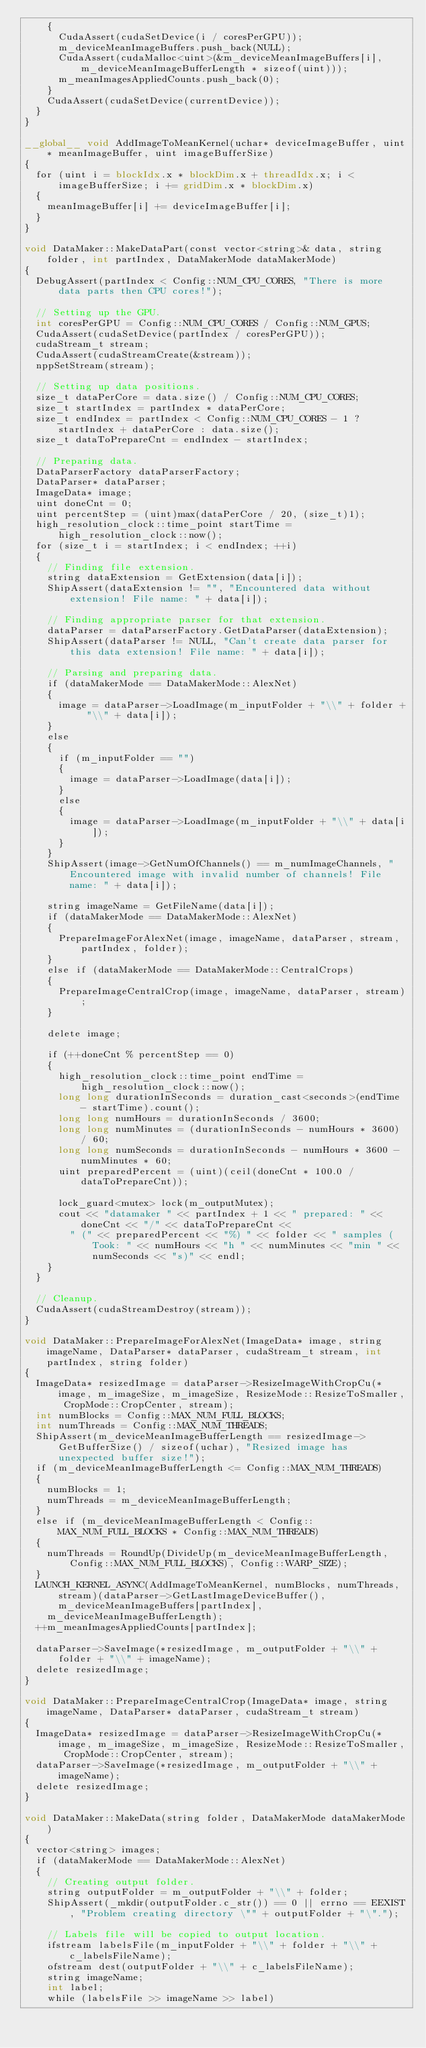<code> <loc_0><loc_0><loc_500><loc_500><_Cuda_>		{
			CudaAssert(cudaSetDevice(i / coresPerGPU));
			m_deviceMeanImageBuffers.push_back(NULL);
			CudaAssert(cudaMalloc<uint>(&m_deviceMeanImageBuffers[i], m_deviceMeanImageBufferLength * sizeof(uint)));
			m_meanImagesAppliedCounts.push_back(0);
		}
		CudaAssert(cudaSetDevice(currentDevice));
	}
}

__global__ void AddImageToMeanKernel(uchar* deviceImageBuffer, uint* meanImageBuffer, uint imageBufferSize)
{
	for (uint i = blockIdx.x * blockDim.x + threadIdx.x; i < imageBufferSize; i += gridDim.x * blockDim.x)
	{
		meanImageBuffer[i] += deviceImageBuffer[i];
	}
}

void DataMaker::MakeDataPart(const vector<string>& data, string folder, int partIndex, DataMakerMode dataMakerMode)
{
	DebugAssert(partIndex < Config::NUM_CPU_CORES, "There is more data parts then CPU cores!");

	// Setting up the GPU.
	int coresPerGPU = Config::NUM_CPU_CORES / Config::NUM_GPUS;
	CudaAssert(cudaSetDevice(partIndex / coresPerGPU));
	cudaStream_t stream;
	CudaAssert(cudaStreamCreate(&stream));
	nppSetStream(stream);

	// Setting up data positions.
	size_t dataPerCore = data.size() / Config::NUM_CPU_CORES;
	size_t startIndex = partIndex * dataPerCore;
	size_t endIndex = partIndex < Config::NUM_CPU_CORES - 1 ? startIndex + dataPerCore : data.size();
	size_t dataToPrepareCnt = endIndex - startIndex;
	
	// Preparing data.
	DataParserFactory dataParserFactory;
	DataParser* dataParser;
	ImageData* image;
	uint doneCnt = 0;
	uint percentStep = (uint)max(dataPerCore / 20, (size_t)1);
	high_resolution_clock::time_point startTime = high_resolution_clock::now();
	for (size_t i = startIndex; i < endIndex; ++i)
	{
		// Finding file extension.
		string dataExtension = GetExtension(data[i]);
		ShipAssert(dataExtension != "", "Encountered data without extension! File name: " + data[i]);

		// Finding appropriate parser for that extension.
		dataParser = dataParserFactory.GetDataParser(dataExtension);
		ShipAssert(dataParser != NULL, "Can't create data parser for this data extension! File name: " + data[i]);

		// Parsing and preparing data.
		if (dataMakerMode == DataMakerMode::AlexNet)
		{
			image = dataParser->LoadImage(m_inputFolder + "\\" + folder + "\\" + data[i]);
		}
		else
		{
			if (m_inputFolder == "")
			{
				image = dataParser->LoadImage(data[i]);
			}
			else
			{
				image = dataParser->LoadImage(m_inputFolder + "\\" + data[i]);
			}
		}
		ShipAssert(image->GetNumOfChannels() == m_numImageChannels, "Encountered image with invalid number of channels! File name: " + data[i]);

		string imageName = GetFileName(data[i]);
		if (dataMakerMode == DataMakerMode::AlexNet)
		{
			PrepareImageForAlexNet(image, imageName, dataParser, stream, partIndex, folder);
		}
		else if (dataMakerMode == DataMakerMode::CentralCrops)
		{
			PrepareImageCentralCrop(image, imageName, dataParser, stream);
		}

		delete image;

		if (++doneCnt % percentStep == 0)
		{
			high_resolution_clock::time_point endTime = high_resolution_clock::now();
			long long durationInSeconds = duration_cast<seconds>(endTime - startTime).count();
			long long numHours = durationInSeconds / 3600;
			long long numMinutes = (durationInSeconds - numHours * 3600) / 60;
			long long numSeconds = durationInSeconds - numHours * 3600 - numMinutes * 60;
			uint preparedPercent = (uint)(ceil(doneCnt * 100.0 / dataToPrepareCnt));

			lock_guard<mutex> lock(m_outputMutex);
			cout << "datamaker " << partIndex + 1 << " prepared: " << doneCnt << "/" << dataToPrepareCnt <<
				" (" << preparedPercent << "%) " << folder << " samples (Took: " << numHours << "h " << numMinutes << "min " << numSeconds << "s)" << endl;
		}
	}

	// Cleanup.
	CudaAssert(cudaStreamDestroy(stream));
}

void DataMaker::PrepareImageForAlexNet(ImageData* image, string imageName, DataParser* dataParser, cudaStream_t stream, int partIndex, string folder)
{
	ImageData* resizedImage = dataParser->ResizeImageWithCropCu(*image, m_imageSize, m_imageSize, ResizeMode::ResizeToSmaller, CropMode::CropCenter, stream);
	int numBlocks = Config::MAX_NUM_FULL_BLOCKS;
	int numThreads = Config::MAX_NUM_THREADS;
	ShipAssert(m_deviceMeanImageBufferLength == resizedImage->GetBufferSize() / sizeof(uchar), "Resized image has unexpected buffer size!");
	if (m_deviceMeanImageBufferLength <= Config::MAX_NUM_THREADS)
	{
		numBlocks = 1;
		numThreads = m_deviceMeanImageBufferLength;
	}
	else if (m_deviceMeanImageBufferLength < Config::MAX_NUM_FULL_BLOCKS * Config::MAX_NUM_THREADS)
	{
		numThreads = RoundUp(DivideUp(m_deviceMeanImageBufferLength, Config::MAX_NUM_FULL_BLOCKS), Config::WARP_SIZE);
	}
	LAUNCH_KERNEL_ASYNC(AddImageToMeanKernel, numBlocks, numThreads, stream)(dataParser->GetLastImageDeviceBuffer(), m_deviceMeanImageBuffers[partIndex],
		m_deviceMeanImageBufferLength);
	++m_meanImagesAppliedCounts[partIndex];
	
	dataParser->SaveImage(*resizedImage, m_outputFolder + "\\" + folder + "\\" + imageName);
	delete resizedImage;
}

void DataMaker::PrepareImageCentralCrop(ImageData* image, string imageName, DataParser* dataParser, cudaStream_t stream)
{
	ImageData* resizedImage = dataParser->ResizeImageWithCropCu(*image, m_imageSize, m_imageSize, ResizeMode::ResizeToSmaller, CropMode::CropCenter, stream);
	dataParser->SaveImage(*resizedImage, m_outputFolder + "\\" + imageName);
	delete resizedImage;
}

void DataMaker::MakeData(string folder, DataMakerMode dataMakerMode)
{
	vector<string> images;
	if (dataMakerMode == DataMakerMode::AlexNet)
	{
		// Creating output folder.
		string outputFolder = m_outputFolder + "\\" + folder;
		ShipAssert(_mkdir(outputFolder.c_str()) == 0 || errno == EEXIST, "Problem creating directory \"" + outputFolder + "\".");

		// Labels file will be copied to output location.
		ifstream labelsFile(m_inputFolder + "\\" + folder + "\\" + c_labelsFileName);
		ofstream dest(outputFolder + "\\" + c_labelsFileName);
		string imageName;
		int label;
		while (labelsFile >> imageName >> label)</code> 